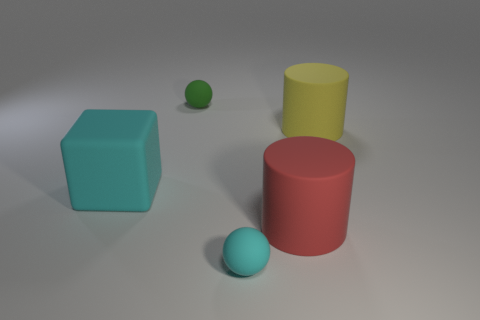There is a object that is right of the tiny green rubber ball and behind the big red rubber cylinder; what color is it? yellow 